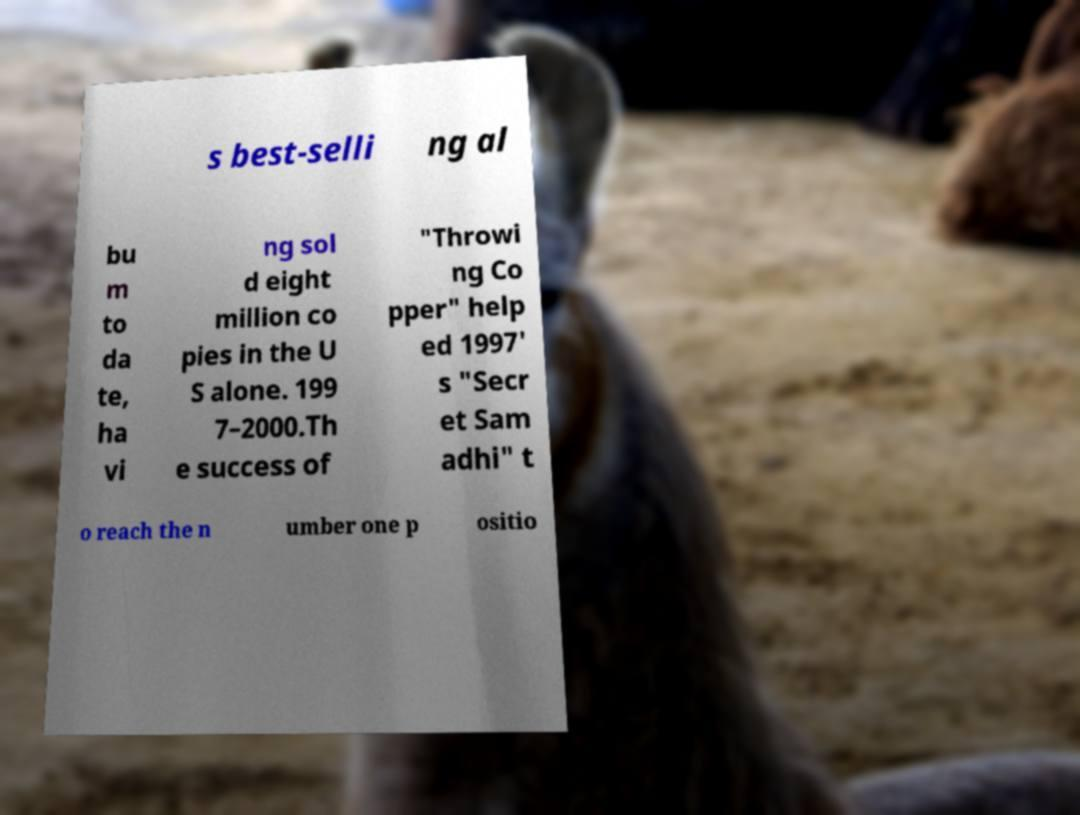Could you assist in decoding the text presented in this image and type it out clearly? s best-selli ng al bu m to da te, ha vi ng sol d eight million co pies in the U S alone. 199 7–2000.Th e success of "Throwi ng Co pper" help ed 1997' s "Secr et Sam adhi" t o reach the n umber one p ositio 